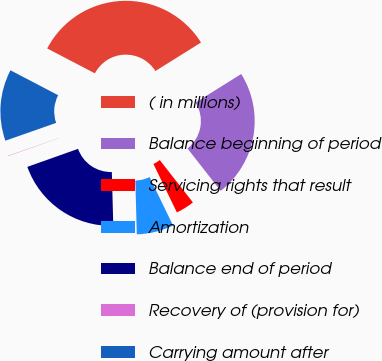Convert chart. <chart><loc_0><loc_0><loc_500><loc_500><pie_chart><fcel>( in millions)<fcel>Balance beginning of period<fcel>Servicing rights that result<fcel>Amortization<fcel>Balance end of period<fcel>Recovery of (provision for)<fcel>Carrying amount after<nl><fcel>33.45%<fcel>23.32%<fcel>3.4%<fcel>6.74%<fcel>19.99%<fcel>0.07%<fcel>13.03%<nl></chart> 